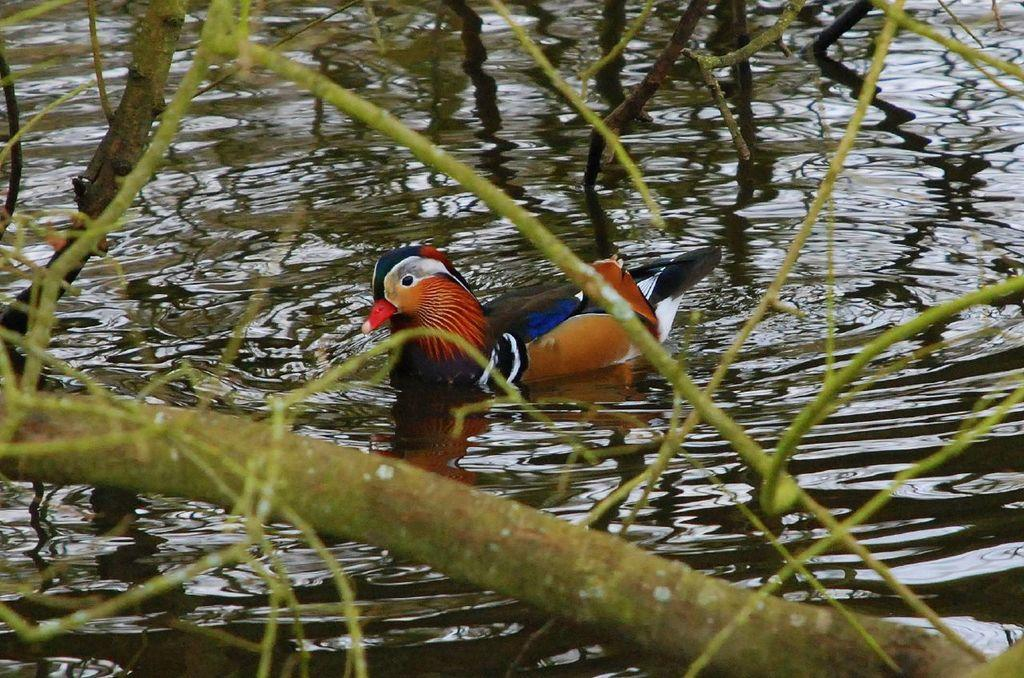What type of animal is in the image? There is a bird in the image. Where is the bird located? The bird is on the water. Can you describe the bird's appearance? The bird has multicolor features. What is visible in the foreground of the image? There is a tree in the foreground of the image. What is the primary element visible in the image? Water is visible in the image. What type of weather can be seen during the bird's trip in the image? There is no indication of a trip or weather in the image; it simply shows a bird on the water. 